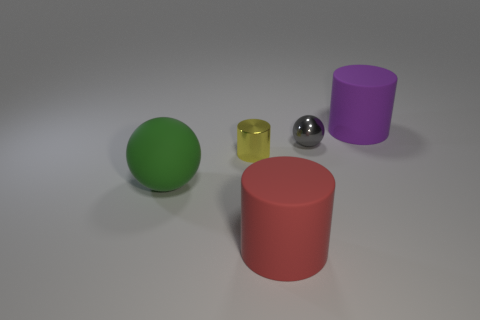Add 1 tiny red matte objects. How many objects exist? 6 Subtract all spheres. How many objects are left? 3 Add 1 red matte objects. How many red matte objects exist? 2 Subtract 0 blue spheres. How many objects are left? 5 Subtract all big matte cylinders. Subtract all red matte objects. How many objects are left? 2 Add 2 big red objects. How many big red objects are left? 3 